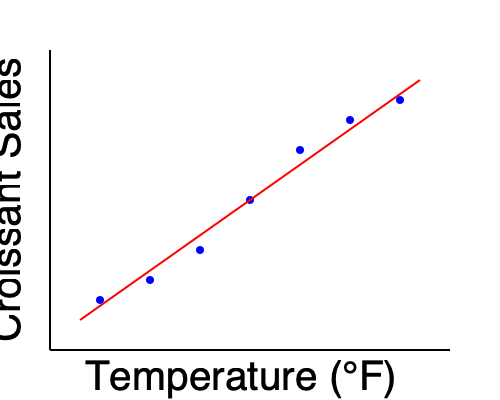Based on the scatter plot and trend line shown, which of the following statements best describes the relationship between temperature and croissant sales at your bakery?

A) As temperature increases, croissant sales decrease linearly
B) As temperature increases, croissant sales increase linearly
C) There is no correlation between temperature and croissant sales
D) As temperature increases, croissant sales increase exponentially To answer this question, we need to analyze the scatter plot and trend line:

1. Observe the data points (blue circles):
   - They show a clear pattern moving from the top-left to the bottom-right of the graph.

2. Interpret the axes:
   - The x-axis represents temperature (°F)
   - The y-axis represents croissant sales

3. Analyze the trend:
   - As we move from left to right (increasing temperature), the data points generally move downward (decreasing sales).

4. Examine the trend line (red line):
   - The trend line is straight, indicating a linear relationship.
   - It has a negative slope, confirming the inverse relationship between temperature and sales.

5. Consider the given options:
   A) This option correctly describes the relationship shown in the graph.
   B) This is the opposite of what the graph shows.
   C) There is a clear correlation, so this is incorrect.
   D) The relationship is linear, not exponential.

Therefore, the correct answer is A: As temperature increases, croissant sales decrease linearly.

This relationship makes sense for a bakery owner, as customers may prefer warm, freshly baked croissants on cooler days rather than hot days.
Answer: A 